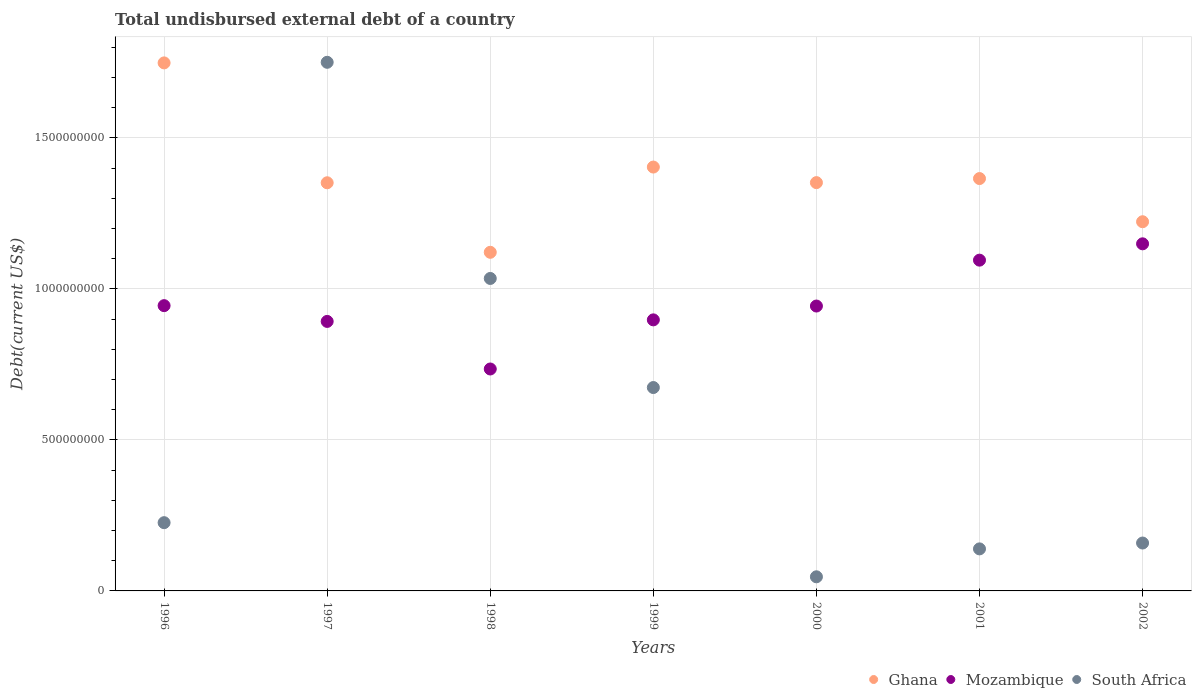What is the total undisbursed external debt in Mozambique in 1996?
Your response must be concise. 9.44e+08. Across all years, what is the maximum total undisbursed external debt in Ghana?
Give a very brief answer. 1.75e+09. Across all years, what is the minimum total undisbursed external debt in Mozambique?
Offer a very short reply. 7.35e+08. What is the total total undisbursed external debt in Mozambique in the graph?
Ensure brevity in your answer.  6.66e+09. What is the difference between the total undisbursed external debt in Mozambique in 1997 and that in 2001?
Give a very brief answer. -2.03e+08. What is the difference between the total undisbursed external debt in Ghana in 1998 and the total undisbursed external debt in South Africa in 1997?
Give a very brief answer. -6.29e+08. What is the average total undisbursed external debt in Ghana per year?
Your answer should be very brief. 1.37e+09. In the year 2000, what is the difference between the total undisbursed external debt in Mozambique and total undisbursed external debt in Ghana?
Provide a short and direct response. -4.09e+08. In how many years, is the total undisbursed external debt in Mozambique greater than 1500000000 US$?
Keep it short and to the point. 0. What is the ratio of the total undisbursed external debt in Ghana in 1996 to that in 2000?
Offer a very short reply. 1.29. Is the total undisbursed external debt in Mozambique in 1997 less than that in 2000?
Your answer should be very brief. Yes. Is the difference between the total undisbursed external debt in Mozambique in 1996 and 1999 greater than the difference between the total undisbursed external debt in Ghana in 1996 and 1999?
Keep it short and to the point. No. What is the difference between the highest and the second highest total undisbursed external debt in South Africa?
Provide a succinct answer. 7.16e+08. What is the difference between the highest and the lowest total undisbursed external debt in South Africa?
Your answer should be compact. 1.70e+09. Is the total undisbursed external debt in Mozambique strictly greater than the total undisbursed external debt in South Africa over the years?
Keep it short and to the point. No. Is the total undisbursed external debt in South Africa strictly less than the total undisbursed external debt in Ghana over the years?
Give a very brief answer. No. How many years are there in the graph?
Your answer should be compact. 7. Where does the legend appear in the graph?
Offer a terse response. Bottom right. How many legend labels are there?
Offer a very short reply. 3. How are the legend labels stacked?
Provide a succinct answer. Horizontal. What is the title of the graph?
Your answer should be very brief. Total undisbursed external debt of a country. What is the label or title of the Y-axis?
Provide a succinct answer. Debt(current US$). What is the Debt(current US$) in Ghana in 1996?
Keep it short and to the point. 1.75e+09. What is the Debt(current US$) of Mozambique in 1996?
Provide a short and direct response. 9.44e+08. What is the Debt(current US$) of South Africa in 1996?
Your response must be concise. 2.26e+08. What is the Debt(current US$) of Ghana in 1997?
Provide a succinct answer. 1.35e+09. What is the Debt(current US$) of Mozambique in 1997?
Keep it short and to the point. 8.92e+08. What is the Debt(current US$) in South Africa in 1997?
Your answer should be compact. 1.75e+09. What is the Debt(current US$) of Ghana in 1998?
Your response must be concise. 1.12e+09. What is the Debt(current US$) in Mozambique in 1998?
Your answer should be compact. 7.35e+08. What is the Debt(current US$) of South Africa in 1998?
Ensure brevity in your answer.  1.03e+09. What is the Debt(current US$) of Ghana in 1999?
Provide a succinct answer. 1.40e+09. What is the Debt(current US$) in Mozambique in 1999?
Make the answer very short. 8.97e+08. What is the Debt(current US$) in South Africa in 1999?
Make the answer very short. 6.73e+08. What is the Debt(current US$) in Ghana in 2000?
Your answer should be compact. 1.35e+09. What is the Debt(current US$) in Mozambique in 2000?
Your answer should be very brief. 9.43e+08. What is the Debt(current US$) in South Africa in 2000?
Keep it short and to the point. 4.67e+07. What is the Debt(current US$) in Ghana in 2001?
Offer a very short reply. 1.37e+09. What is the Debt(current US$) in Mozambique in 2001?
Provide a short and direct response. 1.09e+09. What is the Debt(current US$) in South Africa in 2001?
Ensure brevity in your answer.  1.39e+08. What is the Debt(current US$) of Ghana in 2002?
Make the answer very short. 1.22e+09. What is the Debt(current US$) of Mozambique in 2002?
Your answer should be very brief. 1.15e+09. What is the Debt(current US$) in South Africa in 2002?
Provide a short and direct response. 1.59e+08. Across all years, what is the maximum Debt(current US$) of Ghana?
Ensure brevity in your answer.  1.75e+09. Across all years, what is the maximum Debt(current US$) of Mozambique?
Provide a succinct answer. 1.15e+09. Across all years, what is the maximum Debt(current US$) in South Africa?
Give a very brief answer. 1.75e+09. Across all years, what is the minimum Debt(current US$) in Ghana?
Your response must be concise. 1.12e+09. Across all years, what is the minimum Debt(current US$) in Mozambique?
Provide a succinct answer. 7.35e+08. Across all years, what is the minimum Debt(current US$) in South Africa?
Provide a short and direct response. 4.67e+07. What is the total Debt(current US$) of Ghana in the graph?
Your answer should be compact. 9.56e+09. What is the total Debt(current US$) of Mozambique in the graph?
Give a very brief answer. 6.66e+09. What is the total Debt(current US$) of South Africa in the graph?
Offer a very short reply. 4.03e+09. What is the difference between the Debt(current US$) of Ghana in 1996 and that in 1997?
Give a very brief answer. 3.97e+08. What is the difference between the Debt(current US$) of Mozambique in 1996 and that in 1997?
Ensure brevity in your answer.  5.22e+07. What is the difference between the Debt(current US$) of South Africa in 1996 and that in 1997?
Provide a succinct answer. -1.52e+09. What is the difference between the Debt(current US$) in Ghana in 1996 and that in 1998?
Your answer should be compact. 6.27e+08. What is the difference between the Debt(current US$) of Mozambique in 1996 and that in 1998?
Ensure brevity in your answer.  2.10e+08. What is the difference between the Debt(current US$) of South Africa in 1996 and that in 1998?
Offer a terse response. -8.08e+08. What is the difference between the Debt(current US$) in Ghana in 1996 and that in 1999?
Provide a succinct answer. 3.45e+08. What is the difference between the Debt(current US$) of Mozambique in 1996 and that in 1999?
Ensure brevity in your answer.  4.71e+07. What is the difference between the Debt(current US$) of South Africa in 1996 and that in 1999?
Give a very brief answer. -4.47e+08. What is the difference between the Debt(current US$) in Ghana in 1996 and that in 2000?
Keep it short and to the point. 3.96e+08. What is the difference between the Debt(current US$) of Mozambique in 1996 and that in 2000?
Offer a terse response. 1.30e+06. What is the difference between the Debt(current US$) of South Africa in 1996 and that in 2000?
Give a very brief answer. 1.79e+08. What is the difference between the Debt(current US$) of Ghana in 1996 and that in 2001?
Offer a terse response. 3.83e+08. What is the difference between the Debt(current US$) of Mozambique in 1996 and that in 2001?
Provide a short and direct response. -1.51e+08. What is the difference between the Debt(current US$) in South Africa in 1996 and that in 2001?
Ensure brevity in your answer.  8.68e+07. What is the difference between the Debt(current US$) of Ghana in 1996 and that in 2002?
Your answer should be compact. 5.26e+08. What is the difference between the Debt(current US$) of Mozambique in 1996 and that in 2002?
Keep it short and to the point. -2.05e+08. What is the difference between the Debt(current US$) in South Africa in 1996 and that in 2002?
Your response must be concise. 6.74e+07. What is the difference between the Debt(current US$) in Ghana in 1997 and that in 1998?
Ensure brevity in your answer.  2.30e+08. What is the difference between the Debt(current US$) of Mozambique in 1997 and that in 1998?
Your answer should be very brief. 1.57e+08. What is the difference between the Debt(current US$) in South Africa in 1997 and that in 1998?
Give a very brief answer. 7.16e+08. What is the difference between the Debt(current US$) of Ghana in 1997 and that in 1999?
Offer a terse response. -5.20e+07. What is the difference between the Debt(current US$) of Mozambique in 1997 and that in 1999?
Your answer should be compact. -5.14e+06. What is the difference between the Debt(current US$) of South Africa in 1997 and that in 1999?
Offer a terse response. 1.08e+09. What is the difference between the Debt(current US$) in Ghana in 1997 and that in 2000?
Your response must be concise. -4.96e+05. What is the difference between the Debt(current US$) in Mozambique in 1997 and that in 2000?
Offer a terse response. -5.09e+07. What is the difference between the Debt(current US$) in South Africa in 1997 and that in 2000?
Provide a succinct answer. 1.70e+09. What is the difference between the Debt(current US$) of Ghana in 1997 and that in 2001?
Your answer should be compact. -1.40e+07. What is the difference between the Debt(current US$) of Mozambique in 1997 and that in 2001?
Your response must be concise. -2.03e+08. What is the difference between the Debt(current US$) of South Africa in 1997 and that in 2001?
Make the answer very short. 1.61e+09. What is the difference between the Debt(current US$) of Ghana in 1997 and that in 2002?
Make the answer very short. 1.29e+08. What is the difference between the Debt(current US$) of Mozambique in 1997 and that in 2002?
Your response must be concise. -2.57e+08. What is the difference between the Debt(current US$) of South Africa in 1997 and that in 2002?
Provide a succinct answer. 1.59e+09. What is the difference between the Debt(current US$) in Ghana in 1998 and that in 1999?
Your answer should be compact. -2.82e+08. What is the difference between the Debt(current US$) in Mozambique in 1998 and that in 1999?
Your answer should be very brief. -1.63e+08. What is the difference between the Debt(current US$) of South Africa in 1998 and that in 1999?
Provide a short and direct response. 3.61e+08. What is the difference between the Debt(current US$) of Ghana in 1998 and that in 2000?
Offer a terse response. -2.31e+08. What is the difference between the Debt(current US$) of Mozambique in 1998 and that in 2000?
Offer a terse response. -2.08e+08. What is the difference between the Debt(current US$) in South Africa in 1998 and that in 2000?
Make the answer very short. 9.88e+08. What is the difference between the Debt(current US$) in Ghana in 1998 and that in 2001?
Make the answer very short. -2.44e+08. What is the difference between the Debt(current US$) in Mozambique in 1998 and that in 2001?
Keep it short and to the point. -3.60e+08. What is the difference between the Debt(current US$) in South Africa in 1998 and that in 2001?
Ensure brevity in your answer.  8.95e+08. What is the difference between the Debt(current US$) of Ghana in 1998 and that in 2002?
Keep it short and to the point. -1.01e+08. What is the difference between the Debt(current US$) in Mozambique in 1998 and that in 2002?
Provide a succinct answer. -4.14e+08. What is the difference between the Debt(current US$) in South Africa in 1998 and that in 2002?
Your response must be concise. 8.76e+08. What is the difference between the Debt(current US$) of Ghana in 1999 and that in 2000?
Offer a very short reply. 5.15e+07. What is the difference between the Debt(current US$) of Mozambique in 1999 and that in 2000?
Make the answer very short. -4.58e+07. What is the difference between the Debt(current US$) of South Africa in 1999 and that in 2000?
Provide a short and direct response. 6.27e+08. What is the difference between the Debt(current US$) of Ghana in 1999 and that in 2001?
Keep it short and to the point. 3.81e+07. What is the difference between the Debt(current US$) in Mozambique in 1999 and that in 2001?
Your response must be concise. -1.98e+08. What is the difference between the Debt(current US$) in South Africa in 1999 and that in 2001?
Your response must be concise. 5.34e+08. What is the difference between the Debt(current US$) of Ghana in 1999 and that in 2002?
Ensure brevity in your answer.  1.81e+08. What is the difference between the Debt(current US$) in Mozambique in 1999 and that in 2002?
Your answer should be compact. -2.52e+08. What is the difference between the Debt(current US$) in South Africa in 1999 and that in 2002?
Offer a very short reply. 5.15e+08. What is the difference between the Debt(current US$) in Ghana in 2000 and that in 2001?
Ensure brevity in your answer.  -1.35e+07. What is the difference between the Debt(current US$) in Mozambique in 2000 and that in 2001?
Provide a succinct answer. -1.52e+08. What is the difference between the Debt(current US$) of South Africa in 2000 and that in 2001?
Give a very brief answer. -9.24e+07. What is the difference between the Debt(current US$) in Ghana in 2000 and that in 2002?
Provide a succinct answer. 1.29e+08. What is the difference between the Debt(current US$) in Mozambique in 2000 and that in 2002?
Make the answer very short. -2.06e+08. What is the difference between the Debt(current US$) in South Africa in 2000 and that in 2002?
Provide a succinct answer. -1.12e+08. What is the difference between the Debt(current US$) in Ghana in 2001 and that in 2002?
Keep it short and to the point. 1.43e+08. What is the difference between the Debt(current US$) of Mozambique in 2001 and that in 2002?
Your response must be concise. -5.41e+07. What is the difference between the Debt(current US$) of South Africa in 2001 and that in 2002?
Keep it short and to the point. -1.94e+07. What is the difference between the Debt(current US$) in Ghana in 1996 and the Debt(current US$) in Mozambique in 1997?
Your response must be concise. 8.56e+08. What is the difference between the Debt(current US$) in Ghana in 1996 and the Debt(current US$) in South Africa in 1997?
Your answer should be very brief. -1.98e+06. What is the difference between the Debt(current US$) of Mozambique in 1996 and the Debt(current US$) of South Africa in 1997?
Make the answer very short. -8.06e+08. What is the difference between the Debt(current US$) in Ghana in 1996 and the Debt(current US$) in Mozambique in 1998?
Your response must be concise. 1.01e+09. What is the difference between the Debt(current US$) in Ghana in 1996 and the Debt(current US$) in South Africa in 1998?
Ensure brevity in your answer.  7.14e+08. What is the difference between the Debt(current US$) of Mozambique in 1996 and the Debt(current US$) of South Africa in 1998?
Your answer should be very brief. -9.00e+07. What is the difference between the Debt(current US$) of Ghana in 1996 and the Debt(current US$) of Mozambique in 1999?
Offer a very short reply. 8.51e+08. What is the difference between the Debt(current US$) of Ghana in 1996 and the Debt(current US$) of South Africa in 1999?
Your answer should be compact. 1.07e+09. What is the difference between the Debt(current US$) of Mozambique in 1996 and the Debt(current US$) of South Africa in 1999?
Your response must be concise. 2.71e+08. What is the difference between the Debt(current US$) in Ghana in 1996 and the Debt(current US$) in Mozambique in 2000?
Offer a terse response. 8.05e+08. What is the difference between the Debt(current US$) of Ghana in 1996 and the Debt(current US$) of South Africa in 2000?
Provide a short and direct response. 1.70e+09. What is the difference between the Debt(current US$) in Mozambique in 1996 and the Debt(current US$) in South Africa in 2000?
Give a very brief answer. 8.98e+08. What is the difference between the Debt(current US$) of Ghana in 1996 and the Debt(current US$) of Mozambique in 2001?
Offer a terse response. 6.53e+08. What is the difference between the Debt(current US$) in Ghana in 1996 and the Debt(current US$) in South Africa in 2001?
Your response must be concise. 1.61e+09. What is the difference between the Debt(current US$) in Mozambique in 1996 and the Debt(current US$) in South Africa in 2001?
Your response must be concise. 8.05e+08. What is the difference between the Debt(current US$) in Ghana in 1996 and the Debt(current US$) in Mozambique in 2002?
Ensure brevity in your answer.  5.99e+08. What is the difference between the Debt(current US$) in Ghana in 1996 and the Debt(current US$) in South Africa in 2002?
Offer a very short reply. 1.59e+09. What is the difference between the Debt(current US$) of Mozambique in 1996 and the Debt(current US$) of South Africa in 2002?
Provide a succinct answer. 7.86e+08. What is the difference between the Debt(current US$) of Ghana in 1997 and the Debt(current US$) of Mozambique in 1998?
Keep it short and to the point. 6.16e+08. What is the difference between the Debt(current US$) of Ghana in 1997 and the Debt(current US$) of South Africa in 1998?
Offer a terse response. 3.17e+08. What is the difference between the Debt(current US$) of Mozambique in 1997 and the Debt(current US$) of South Africa in 1998?
Make the answer very short. -1.42e+08. What is the difference between the Debt(current US$) of Ghana in 1997 and the Debt(current US$) of Mozambique in 1999?
Provide a short and direct response. 4.54e+08. What is the difference between the Debt(current US$) of Ghana in 1997 and the Debt(current US$) of South Africa in 1999?
Ensure brevity in your answer.  6.78e+08. What is the difference between the Debt(current US$) of Mozambique in 1997 and the Debt(current US$) of South Africa in 1999?
Provide a short and direct response. 2.19e+08. What is the difference between the Debt(current US$) of Ghana in 1997 and the Debt(current US$) of Mozambique in 2000?
Keep it short and to the point. 4.08e+08. What is the difference between the Debt(current US$) in Ghana in 1997 and the Debt(current US$) in South Africa in 2000?
Your response must be concise. 1.30e+09. What is the difference between the Debt(current US$) in Mozambique in 1997 and the Debt(current US$) in South Africa in 2000?
Offer a very short reply. 8.45e+08. What is the difference between the Debt(current US$) of Ghana in 1997 and the Debt(current US$) of Mozambique in 2001?
Make the answer very short. 2.56e+08. What is the difference between the Debt(current US$) in Ghana in 1997 and the Debt(current US$) in South Africa in 2001?
Your answer should be very brief. 1.21e+09. What is the difference between the Debt(current US$) of Mozambique in 1997 and the Debt(current US$) of South Africa in 2001?
Keep it short and to the point. 7.53e+08. What is the difference between the Debt(current US$) of Ghana in 1997 and the Debt(current US$) of Mozambique in 2002?
Keep it short and to the point. 2.02e+08. What is the difference between the Debt(current US$) of Ghana in 1997 and the Debt(current US$) of South Africa in 2002?
Provide a short and direct response. 1.19e+09. What is the difference between the Debt(current US$) of Mozambique in 1997 and the Debt(current US$) of South Africa in 2002?
Make the answer very short. 7.34e+08. What is the difference between the Debt(current US$) of Ghana in 1998 and the Debt(current US$) of Mozambique in 1999?
Give a very brief answer. 2.24e+08. What is the difference between the Debt(current US$) in Ghana in 1998 and the Debt(current US$) in South Africa in 1999?
Offer a terse response. 4.48e+08. What is the difference between the Debt(current US$) of Mozambique in 1998 and the Debt(current US$) of South Africa in 1999?
Your response must be concise. 6.14e+07. What is the difference between the Debt(current US$) in Ghana in 1998 and the Debt(current US$) in Mozambique in 2000?
Keep it short and to the point. 1.78e+08. What is the difference between the Debt(current US$) in Ghana in 1998 and the Debt(current US$) in South Africa in 2000?
Offer a terse response. 1.07e+09. What is the difference between the Debt(current US$) of Mozambique in 1998 and the Debt(current US$) of South Africa in 2000?
Make the answer very short. 6.88e+08. What is the difference between the Debt(current US$) in Ghana in 1998 and the Debt(current US$) in Mozambique in 2001?
Make the answer very short. 2.60e+07. What is the difference between the Debt(current US$) in Ghana in 1998 and the Debt(current US$) in South Africa in 2001?
Make the answer very short. 9.82e+08. What is the difference between the Debt(current US$) of Mozambique in 1998 and the Debt(current US$) of South Africa in 2001?
Provide a succinct answer. 5.96e+08. What is the difference between the Debt(current US$) of Ghana in 1998 and the Debt(current US$) of Mozambique in 2002?
Make the answer very short. -2.81e+07. What is the difference between the Debt(current US$) of Ghana in 1998 and the Debt(current US$) of South Africa in 2002?
Your answer should be very brief. 9.62e+08. What is the difference between the Debt(current US$) in Mozambique in 1998 and the Debt(current US$) in South Africa in 2002?
Provide a succinct answer. 5.76e+08. What is the difference between the Debt(current US$) of Ghana in 1999 and the Debt(current US$) of Mozambique in 2000?
Provide a short and direct response. 4.60e+08. What is the difference between the Debt(current US$) of Ghana in 1999 and the Debt(current US$) of South Africa in 2000?
Your response must be concise. 1.36e+09. What is the difference between the Debt(current US$) in Mozambique in 1999 and the Debt(current US$) in South Africa in 2000?
Provide a succinct answer. 8.51e+08. What is the difference between the Debt(current US$) of Ghana in 1999 and the Debt(current US$) of Mozambique in 2001?
Give a very brief answer. 3.08e+08. What is the difference between the Debt(current US$) in Ghana in 1999 and the Debt(current US$) in South Africa in 2001?
Provide a succinct answer. 1.26e+09. What is the difference between the Debt(current US$) of Mozambique in 1999 and the Debt(current US$) of South Africa in 2001?
Offer a terse response. 7.58e+08. What is the difference between the Debt(current US$) of Ghana in 1999 and the Debt(current US$) of Mozambique in 2002?
Give a very brief answer. 2.54e+08. What is the difference between the Debt(current US$) in Ghana in 1999 and the Debt(current US$) in South Africa in 2002?
Give a very brief answer. 1.24e+09. What is the difference between the Debt(current US$) in Mozambique in 1999 and the Debt(current US$) in South Africa in 2002?
Your answer should be very brief. 7.39e+08. What is the difference between the Debt(current US$) in Ghana in 2000 and the Debt(current US$) in Mozambique in 2001?
Your answer should be very brief. 2.57e+08. What is the difference between the Debt(current US$) in Ghana in 2000 and the Debt(current US$) in South Africa in 2001?
Your response must be concise. 1.21e+09. What is the difference between the Debt(current US$) of Mozambique in 2000 and the Debt(current US$) of South Africa in 2001?
Provide a short and direct response. 8.04e+08. What is the difference between the Debt(current US$) in Ghana in 2000 and the Debt(current US$) in Mozambique in 2002?
Ensure brevity in your answer.  2.03e+08. What is the difference between the Debt(current US$) of Ghana in 2000 and the Debt(current US$) of South Africa in 2002?
Keep it short and to the point. 1.19e+09. What is the difference between the Debt(current US$) of Mozambique in 2000 and the Debt(current US$) of South Africa in 2002?
Give a very brief answer. 7.85e+08. What is the difference between the Debt(current US$) in Ghana in 2001 and the Debt(current US$) in Mozambique in 2002?
Make the answer very short. 2.16e+08. What is the difference between the Debt(current US$) in Ghana in 2001 and the Debt(current US$) in South Africa in 2002?
Your answer should be very brief. 1.21e+09. What is the difference between the Debt(current US$) in Mozambique in 2001 and the Debt(current US$) in South Africa in 2002?
Your response must be concise. 9.36e+08. What is the average Debt(current US$) in Ghana per year?
Offer a very short reply. 1.37e+09. What is the average Debt(current US$) of Mozambique per year?
Give a very brief answer. 9.51e+08. What is the average Debt(current US$) of South Africa per year?
Your response must be concise. 5.75e+08. In the year 1996, what is the difference between the Debt(current US$) in Ghana and Debt(current US$) in Mozambique?
Keep it short and to the point. 8.04e+08. In the year 1996, what is the difference between the Debt(current US$) in Ghana and Debt(current US$) in South Africa?
Make the answer very short. 1.52e+09. In the year 1996, what is the difference between the Debt(current US$) of Mozambique and Debt(current US$) of South Africa?
Provide a succinct answer. 7.18e+08. In the year 1997, what is the difference between the Debt(current US$) in Ghana and Debt(current US$) in Mozambique?
Give a very brief answer. 4.59e+08. In the year 1997, what is the difference between the Debt(current US$) in Ghana and Debt(current US$) in South Africa?
Ensure brevity in your answer.  -3.99e+08. In the year 1997, what is the difference between the Debt(current US$) in Mozambique and Debt(current US$) in South Africa?
Provide a succinct answer. -8.58e+08. In the year 1998, what is the difference between the Debt(current US$) in Ghana and Debt(current US$) in Mozambique?
Offer a very short reply. 3.86e+08. In the year 1998, what is the difference between the Debt(current US$) in Ghana and Debt(current US$) in South Africa?
Provide a succinct answer. 8.66e+07. In the year 1998, what is the difference between the Debt(current US$) of Mozambique and Debt(current US$) of South Africa?
Your answer should be compact. -3.00e+08. In the year 1999, what is the difference between the Debt(current US$) of Ghana and Debt(current US$) of Mozambique?
Make the answer very short. 5.06e+08. In the year 1999, what is the difference between the Debt(current US$) in Ghana and Debt(current US$) in South Africa?
Keep it short and to the point. 7.30e+08. In the year 1999, what is the difference between the Debt(current US$) of Mozambique and Debt(current US$) of South Africa?
Offer a very short reply. 2.24e+08. In the year 2000, what is the difference between the Debt(current US$) of Ghana and Debt(current US$) of Mozambique?
Keep it short and to the point. 4.09e+08. In the year 2000, what is the difference between the Debt(current US$) of Ghana and Debt(current US$) of South Africa?
Provide a succinct answer. 1.30e+09. In the year 2000, what is the difference between the Debt(current US$) of Mozambique and Debt(current US$) of South Africa?
Provide a short and direct response. 8.96e+08. In the year 2001, what is the difference between the Debt(current US$) of Ghana and Debt(current US$) of Mozambique?
Offer a very short reply. 2.70e+08. In the year 2001, what is the difference between the Debt(current US$) in Ghana and Debt(current US$) in South Africa?
Ensure brevity in your answer.  1.23e+09. In the year 2001, what is the difference between the Debt(current US$) of Mozambique and Debt(current US$) of South Africa?
Offer a terse response. 9.56e+08. In the year 2002, what is the difference between the Debt(current US$) of Ghana and Debt(current US$) of Mozambique?
Keep it short and to the point. 7.31e+07. In the year 2002, what is the difference between the Debt(current US$) in Ghana and Debt(current US$) in South Africa?
Ensure brevity in your answer.  1.06e+09. In the year 2002, what is the difference between the Debt(current US$) in Mozambique and Debt(current US$) in South Africa?
Your response must be concise. 9.91e+08. What is the ratio of the Debt(current US$) of Ghana in 1996 to that in 1997?
Provide a short and direct response. 1.29. What is the ratio of the Debt(current US$) in Mozambique in 1996 to that in 1997?
Your answer should be compact. 1.06. What is the ratio of the Debt(current US$) in South Africa in 1996 to that in 1997?
Keep it short and to the point. 0.13. What is the ratio of the Debt(current US$) in Ghana in 1996 to that in 1998?
Your response must be concise. 1.56. What is the ratio of the Debt(current US$) of Mozambique in 1996 to that in 1998?
Offer a terse response. 1.29. What is the ratio of the Debt(current US$) of South Africa in 1996 to that in 1998?
Offer a very short reply. 0.22. What is the ratio of the Debt(current US$) in Ghana in 1996 to that in 1999?
Offer a very short reply. 1.25. What is the ratio of the Debt(current US$) of Mozambique in 1996 to that in 1999?
Provide a short and direct response. 1.05. What is the ratio of the Debt(current US$) in South Africa in 1996 to that in 1999?
Your answer should be very brief. 0.34. What is the ratio of the Debt(current US$) of Ghana in 1996 to that in 2000?
Keep it short and to the point. 1.29. What is the ratio of the Debt(current US$) in Mozambique in 1996 to that in 2000?
Offer a terse response. 1. What is the ratio of the Debt(current US$) of South Africa in 1996 to that in 2000?
Provide a succinct answer. 4.83. What is the ratio of the Debt(current US$) of Ghana in 1996 to that in 2001?
Provide a short and direct response. 1.28. What is the ratio of the Debt(current US$) of Mozambique in 1996 to that in 2001?
Keep it short and to the point. 0.86. What is the ratio of the Debt(current US$) of South Africa in 1996 to that in 2001?
Keep it short and to the point. 1.62. What is the ratio of the Debt(current US$) of Ghana in 1996 to that in 2002?
Make the answer very short. 1.43. What is the ratio of the Debt(current US$) in Mozambique in 1996 to that in 2002?
Offer a terse response. 0.82. What is the ratio of the Debt(current US$) of South Africa in 1996 to that in 2002?
Make the answer very short. 1.43. What is the ratio of the Debt(current US$) in Ghana in 1997 to that in 1998?
Ensure brevity in your answer.  1.21. What is the ratio of the Debt(current US$) of Mozambique in 1997 to that in 1998?
Your answer should be very brief. 1.21. What is the ratio of the Debt(current US$) in South Africa in 1997 to that in 1998?
Offer a terse response. 1.69. What is the ratio of the Debt(current US$) in Ghana in 1997 to that in 1999?
Give a very brief answer. 0.96. What is the ratio of the Debt(current US$) of South Africa in 1997 to that in 1999?
Make the answer very short. 2.6. What is the ratio of the Debt(current US$) in Mozambique in 1997 to that in 2000?
Your answer should be very brief. 0.95. What is the ratio of the Debt(current US$) in South Africa in 1997 to that in 2000?
Your answer should be very brief. 37.44. What is the ratio of the Debt(current US$) in Mozambique in 1997 to that in 2001?
Make the answer very short. 0.81. What is the ratio of the Debt(current US$) of South Africa in 1997 to that in 2001?
Offer a terse response. 12.57. What is the ratio of the Debt(current US$) of Ghana in 1997 to that in 2002?
Ensure brevity in your answer.  1.11. What is the ratio of the Debt(current US$) in Mozambique in 1997 to that in 2002?
Give a very brief answer. 0.78. What is the ratio of the Debt(current US$) of South Africa in 1997 to that in 2002?
Your response must be concise. 11.04. What is the ratio of the Debt(current US$) in Ghana in 1998 to that in 1999?
Offer a very short reply. 0.8. What is the ratio of the Debt(current US$) in Mozambique in 1998 to that in 1999?
Your answer should be compact. 0.82. What is the ratio of the Debt(current US$) of South Africa in 1998 to that in 1999?
Give a very brief answer. 1.54. What is the ratio of the Debt(current US$) of Ghana in 1998 to that in 2000?
Your answer should be very brief. 0.83. What is the ratio of the Debt(current US$) of Mozambique in 1998 to that in 2000?
Make the answer very short. 0.78. What is the ratio of the Debt(current US$) in South Africa in 1998 to that in 2000?
Make the answer very short. 22.13. What is the ratio of the Debt(current US$) in Ghana in 1998 to that in 2001?
Your answer should be compact. 0.82. What is the ratio of the Debt(current US$) of Mozambique in 1998 to that in 2001?
Your response must be concise. 0.67. What is the ratio of the Debt(current US$) of South Africa in 1998 to that in 2001?
Ensure brevity in your answer.  7.43. What is the ratio of the Debt(current US$) of Ghana in 1998 to that in 2002?
Keep it short and to the point. 0.92. What is the ratio of the Debt(current US$) of Mozambique in 1998 to that in 2002?
Keep it short and to the point. 0.64. What is the ratio of the Debt(current US$) in South Africa in 1998 to that in 2002?
Your answer should be very brief. 6.52. What is the ratio of the Debt(current US$) of Ghana in 1999 to that in 2000?
Your response must be concise. 1.04. What is the ratio of the Debt(current US$) in Mozambique in 1999 to that in 2000?
Offer a very short reply. 0.95. What is the ratio of the Debt(current US$) of South Africa in 1999 to that in 2000?
Provide a succinct answer. 14.4. What is the ratio of the Debt(current US$) in Ghana in 1999 to that in 2001?
Give a very brief answer. 1.03. What is the ratio of the Debt(current US$) of Mozambique in 1999 to that in 2001?
Ensure brevity in your answer.  0.82. What is the ratio of the Debt(current US$) in South Africa in 1999 to that in 2001?
Your response must be concise. 4.84. What is the ratio of the Debt(current US$) in Ghana in 1999 to that in 2002?
Provide a short and direct response. 1.15. What is the ratio of the Debt(current US$) of Mozambique in 1999 to that in 2002?
Your answer should be very brief. 0.78. What is the ratio of the Debt(current US$) of South Africa in 1999 to that in 2002?
Give a very brief answer. 4.25. What is the ratio of the Debt(current US$) in Mozambique in 2000 to that in 2001?
Your answer should be compact. 0.86. What is the ratio of the Debt(current US$) in South Africa in 2000 to that in 2001?
Your answer should be compact. 0.34. What is the ratio of the Debt(current US$) in Ghana in 2000 to that in 2002?
Give a very brief answer. 1.11. What is the ratio of the Debt(current US$) of Mozambique in 2000 to that in 2002?
Offer a terse response. 0.82. What is the ratio of the Debt(current US$) in South Africa in 2000 to that in 2002?
Your response must be concise. 0.29. What is the ratio of the Debt(current US$) in Ghana in 2001 to that in 2002?
Provide a short and direct response. 1.12. What is the ratio of the Debt(current US$) in Mozambique in 2001 to that in 2002?
Make the answer very short. 0.95. What is the ratio of the Debt(current US$) of South Africa in 2001 to that in 2002?
Keep it short and to the point. 0.88. What is the difference between the highest and the second highest Debt(current US$) in Ghana?
Your answer should be very brief. 3.45e+08. What is the difference between the highest and the second highest Debt(current US$) in Mozambique?
Provide a succinct answer. 5.41e+07. What is the difference between the highest and the second highest Debt(current US$) in South Africa?
Your answer should be compact. 7.16e+08. What is the difference between the highest and the lowest Debt(current US$) in Ghana?
Provide a succinct answer. 6.27e+08. What is the difference between the highest and the lowest Debt(current US$) of Mozambique?
Make the answer very short. 4.14e+08. What is the difference between the highest and the lowest Debt(current US$) of South Africa?
Provide a succinct answer. 1.70e+09. 